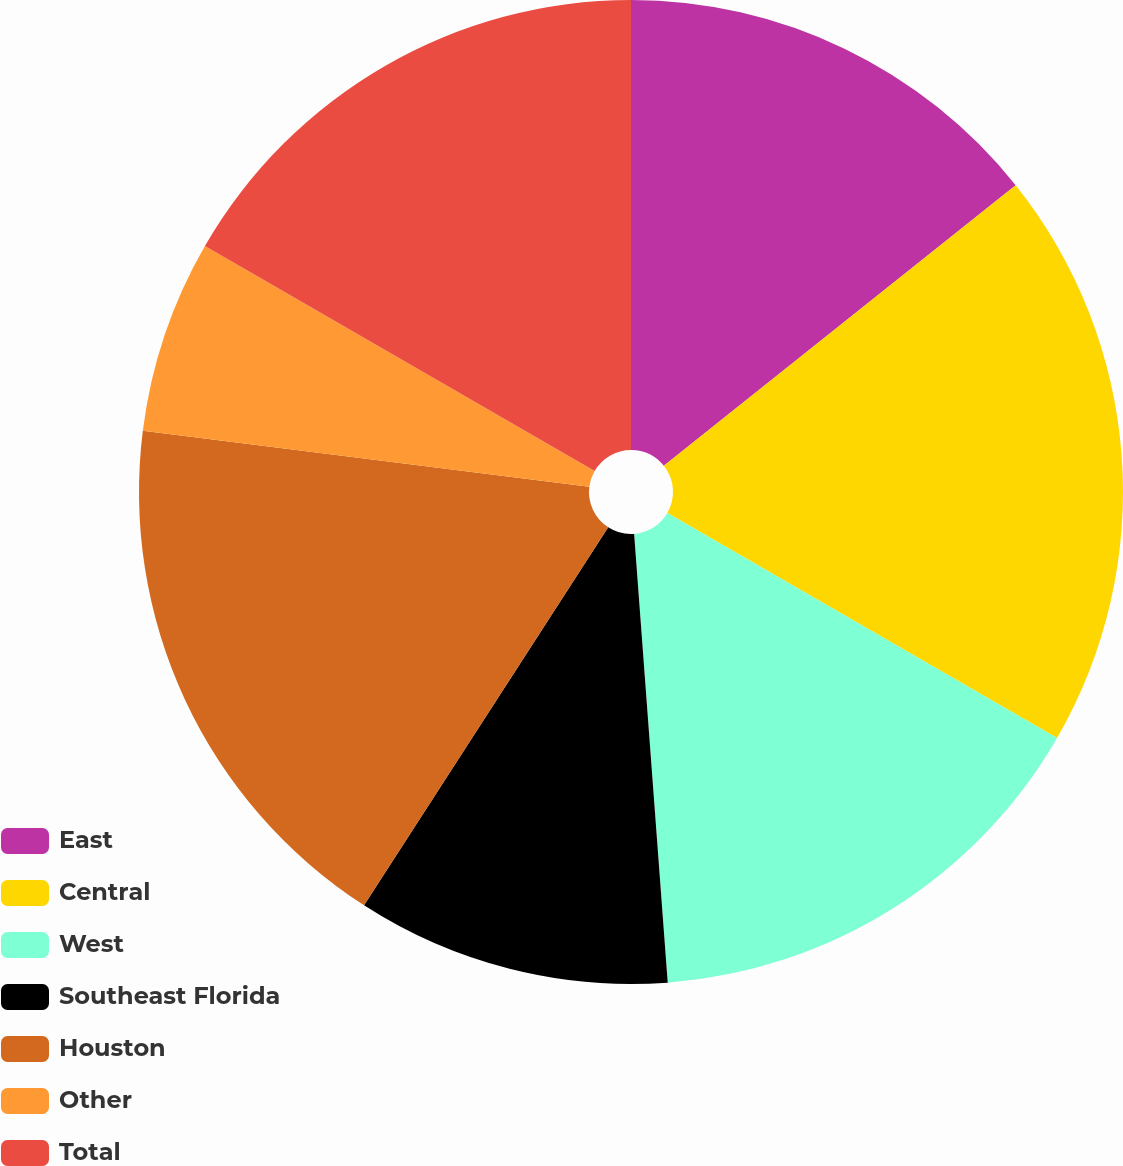<chart> <loc_0><loc_0><loc_500><loc_500><pie_chart><fcel>East<fcel>Central<fcel>West<fcel>Southeast Florida<fcel>Houston<fcel>Other<fcel>Total<nl><fcel>14.29%<fcel>19.05%<fcel>15.48%<fcel>10.32%<fcel>17.86%<fcel>6.35%<fcel>16.67%<nl></chart> 